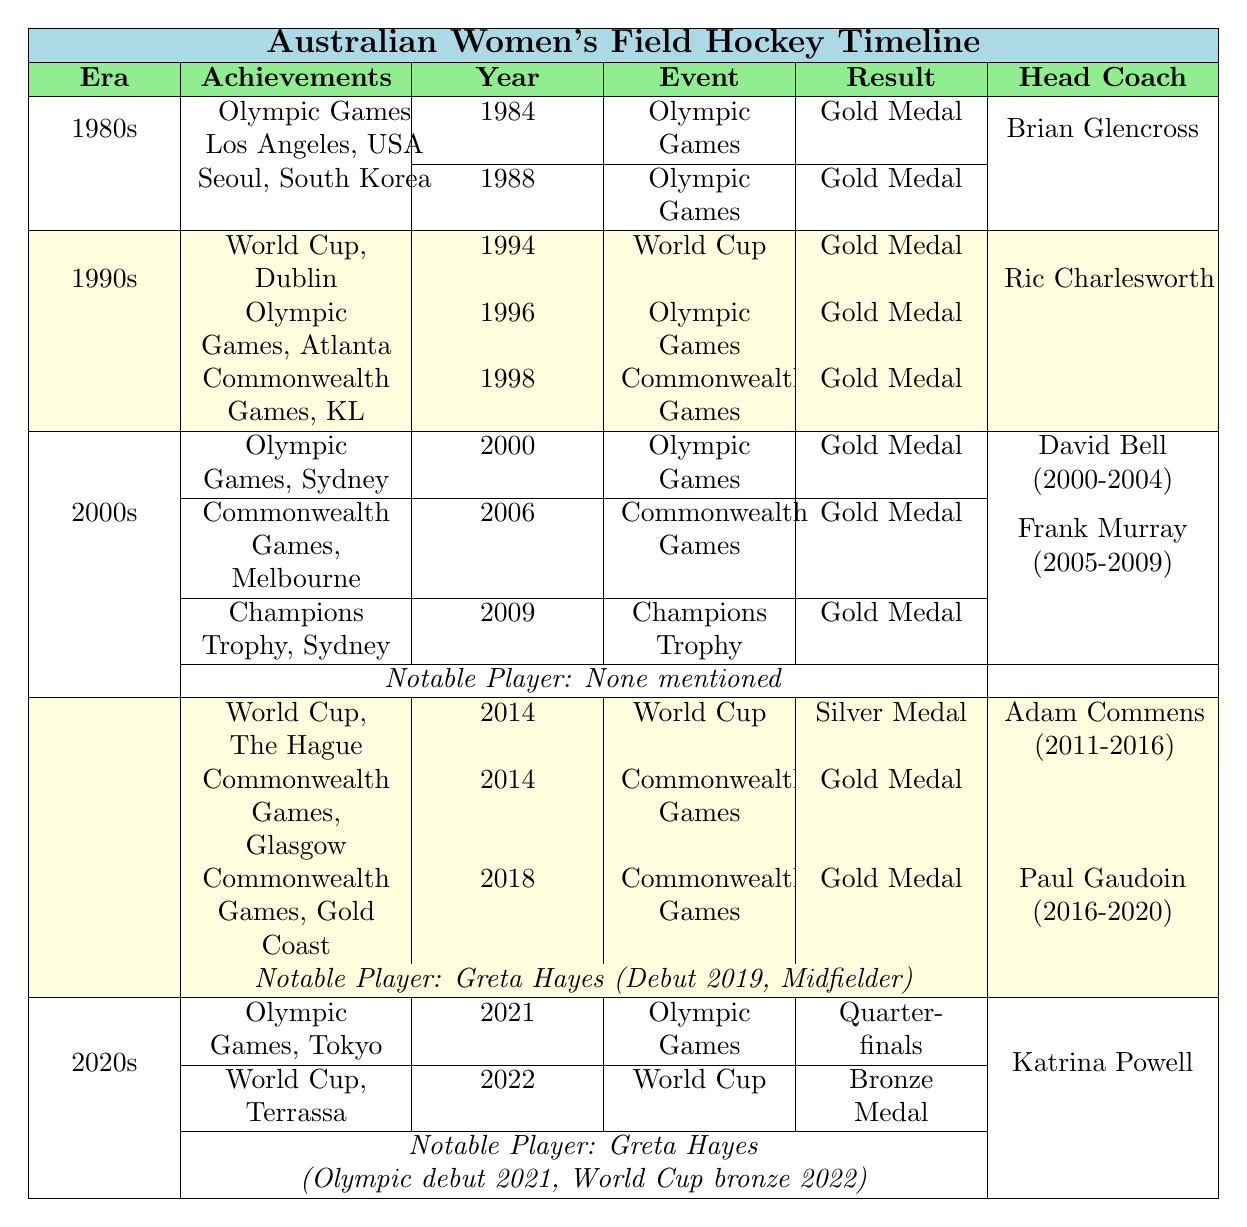What major achievement did the Australian women's field hockey team accomplish in 1984? The table states that in 1984, the Australian women's field hockey team won a gold medal at the Olympic Games in Los Angeles, USA.
Answer: Gold Medal at the Olympic Games Who was the head coach during the 1990s? The head coach for the Australian women's field hockey team during the 1990s, as listed in the table, was Ric Charlesworth.
Answer: Ric Charlesworth How many gold medals did Australia win in the 2000s? From the table, the Australian women's field hockey team won three gold medals in the 2000s: one at the Olympic Games in Sydney (2000), one at the Commonwealth Games in Melbourne (2006), and one at the Champions Trophy in Sydney (2009). So, the total is 3 gold medals.
Answer: 3 What notable achievements did Greta Hayes have in the 2020s? According to the table, Greta Hayes had two notable achievements in the 2020s: she made her Olympic debut in Tokyo 2021 and was a World Cup bronze medalist in 2022.
Answer: Olympic debut in 2021 and World Cup bronze in 2022 Did the Australian women's field hockey team win a silver medal in the 2010s? Yes, the table indicates that in 2014, the team won a silver medal at the World Cup held in The Hague, Netherlands.
Answer: Yes What event did Australia participate in 2009 and what was the outcome? The table shows that in 2009, Australia participated in the Champions Trophy held in Sydney and won a gold medal.
Answer: Gold Medal at the Champions Trophy How many different head coaches did the team have in the 2010s? The table lists two head coaches for the 2010s: Adam Commens (2011-2016) and Paul Gaudoin (2016-2020), which totals to two coaching periods.
Answer: 2 What was the team's most recent achievement as of 2022? The most recent achievement mentioned in the table as of 2022 is winning a bronze medal at the World Cup held in Terrassa, Spain.
Answer: Bronze Medal at the World Cup Which era had the most gold medal achievements? By examining the table, the 1990s had the most gold medal achievements, with a total of three: the World Cup in 1994, Olympic Games in 1996, and Commonwealth Games in 1998.
Answer: 1990s Was there any notable player mentioned for the 1980s? According to the table, there is no notable player mentioned for the 1980s. The only significant detail listed is regarding the head coach and achievements.
Answer: No 